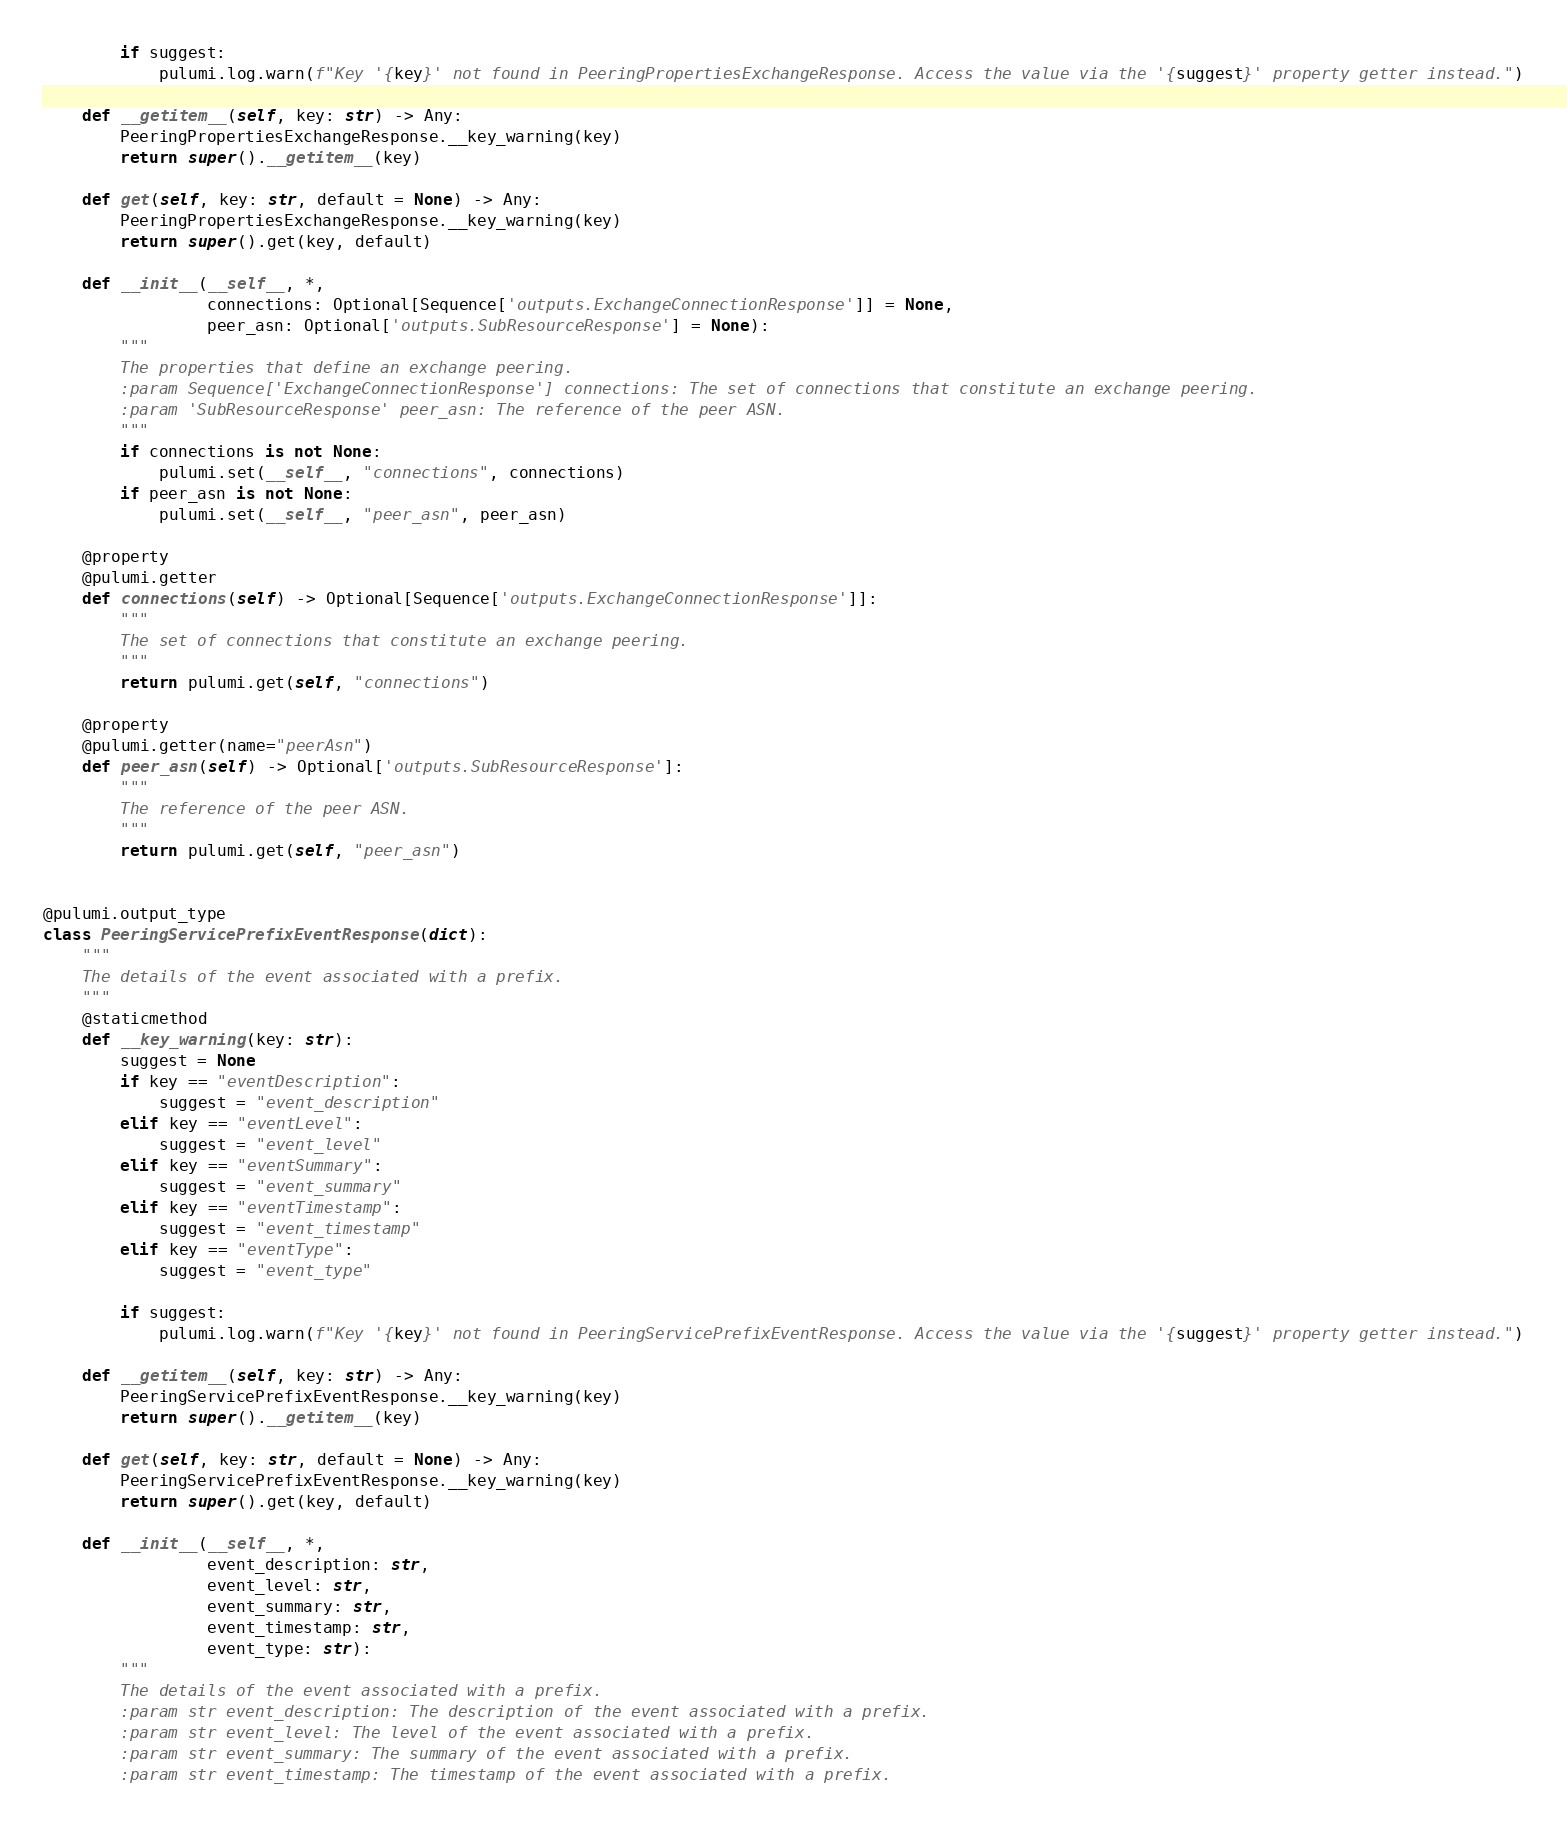<code> <loc_0><loc_0><loc_500><loc_500><_Python_>
        if suggest:
            pulumi.log.warn(f"Key '{key}' not found in PeeringPropertiesExchangeResponse. Access the value via the '{suggest}' property getter instead.")

    def __getitem__(self, key: str) -> Any:
        PeeringPropertiesExchangeResponse.__key_warning(key)
        return super().__getitem__(key)

    def get(self, key: str, default = None) -> Any:
        PeeringPropertiesExchangeResponse.__key_warning(key)
        return super().get(key, default)

    def __init__(__self__, *,
                 connections: Optional[Sequence['outputs.ExchangeConnectionResponse']] = None,
                 peer_asn: Optional['outputs.SubResourceResponse'] = None):
        """
        The properties that define an exchange peering.
        :param Sequence['ExchangeConnectionResponse'] connections: The set of connections that constitute an exchange peering.
        :param 'SubResourceResponse' peer_asn: The reference of the peer ASN.
        """
        if connections is not None:
            pulumi.set(__self__, "connections", connections)
        if peer_asn is not None:
            pulumi.set(__self__, "peer_asn", peer_asn)

    @property
    @pulumi.getter
    def connections(self) -> Optional[Sequence['outputs.ExchangeConnectionResponse']]:
        """
        The set of connections that constitute an exchange peering.
        """
        return pulumi.get(self, "connections")

    @property
    @pulumi.getter(name="peerAsn")
    def peer_asn(self) -> Optional['outputs.SubResourceResponse']:
        """
        The reference of the peer ASN.
        """
        return pulumi.get(self, "peer_asn")


@pulumi.output_type
class PeeringServicePrefixEventResponse(dict):
    """
    The details of the event associated with a prefix.
    """
    @staticmethod
    def __key_warning(key: str):
        suggest = None
        if key == "eventDescription":
            suggest = "event_description"
        elif key == "eventLevel":
            suggest = "event_level"
        elif key == "eventSummary":
            suggest = "event_summary"
        elif key == "eventTimestamp":
            suggest = "event_timestamp"
        elif key == "eventType":
            suggest = "event_type"

        if suggest:
            pulumi.log.warn(f"Key '{key}' not found in PeeringServicePrefixEventResponse. Access the value via the '{suggest}' property getter instead.")

    def __getitem__(self, key: str) -> Any:
        PeeringServicePrefixEventResponse.__key_warning(key)
        return super().__getitem__(key)

    def get(self, key: str, default = None) -> Any:
        PeeringServicePrefixEventResponse.__key_warning(key)
        return super().get(key, default)

    def __init__(__self__, *,
                 event_description: str,
                 event_level: str,
                 event_summary: str,
                 event_timestamp: str,
                 event_type: str):
        """
        The details of the event associated with a prefix.
        :param str event_description: The description of the event associated with a prefix.
        :param str event_level: The level of the event associated with a prefix.
        :param str event_summary: The summary of the event associated with a prefix.
        :param str event_timestamp: The timestamp of the event associated with a prefix.</code> 